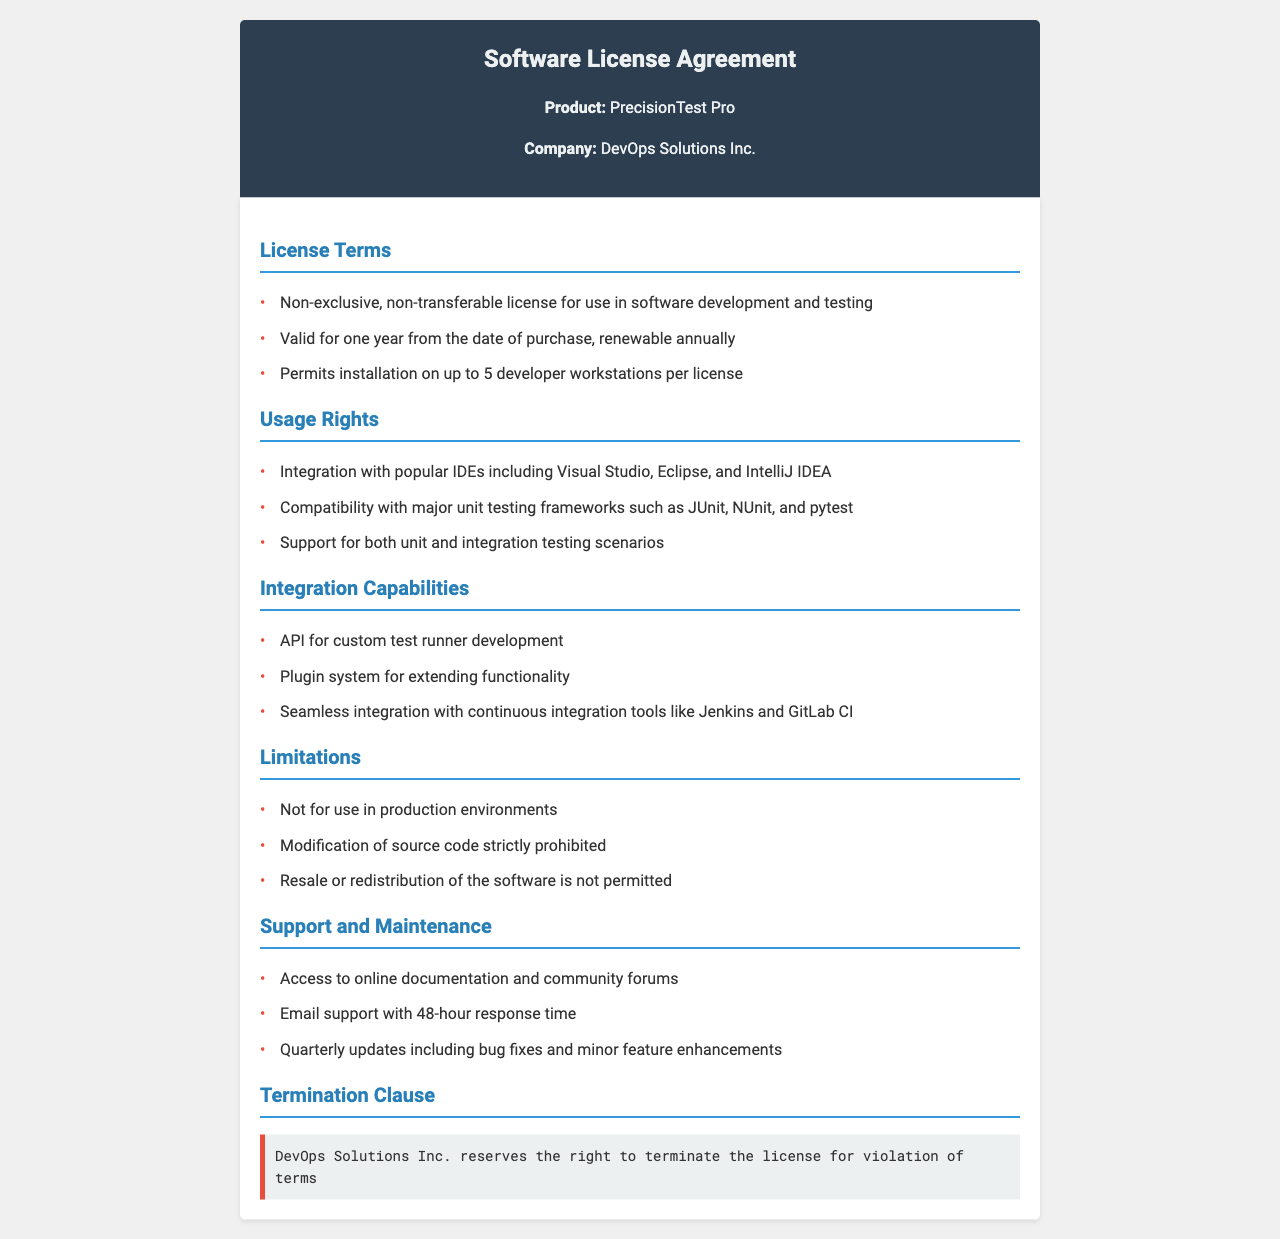What is the product name? The product name is mentioned at the top of the document under the product section.
Answer: PrecisionTest Pro How many developer workstations can one license cover? The document states that one license permits installation on up to 5 developer workstations.
Answer: 5 What is the license term duration? The license term duration is indicated in the license terms section.
Answer: One year Which IDEs are mentioned for integration? The usage rights section lists the IDEs compatible with the software.
Answer: Visual Studio, Eclipse, IntelliJ IDEA What is the response time for email support? The support and maintenance section specifies the response time for email support.
Answer: 48-hour What rights does DevOps Solutions Inc. reserve regarding the license? The termination clause mentions the rights reserved by DevOps Solutions Inc.
Answer: Termination for violation of terms Is modification of source code permitted? The limitations section of the document clearly states the rules regarding source code.
Answer: Strictly prohibited What type of testing scenarios does the software support? The usage rights section details the testing scenarios supported by the software.
Answer: Unit and integration testing scenarios 